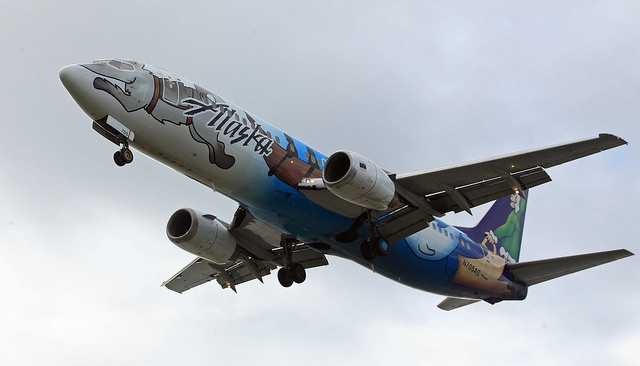Describe the objects in this image and their specific colors. I can see a airplane in lightgray, black, gray, and darkgray tones in this image. 